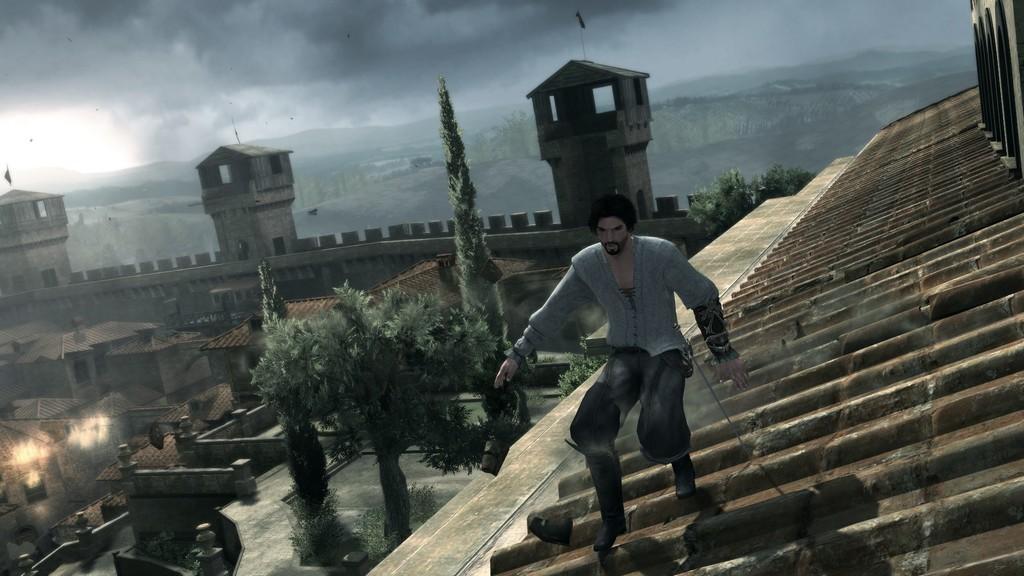Can you describe this image briefly? This is an animated image. A person is standing on a roof. There are trees and buildings. 